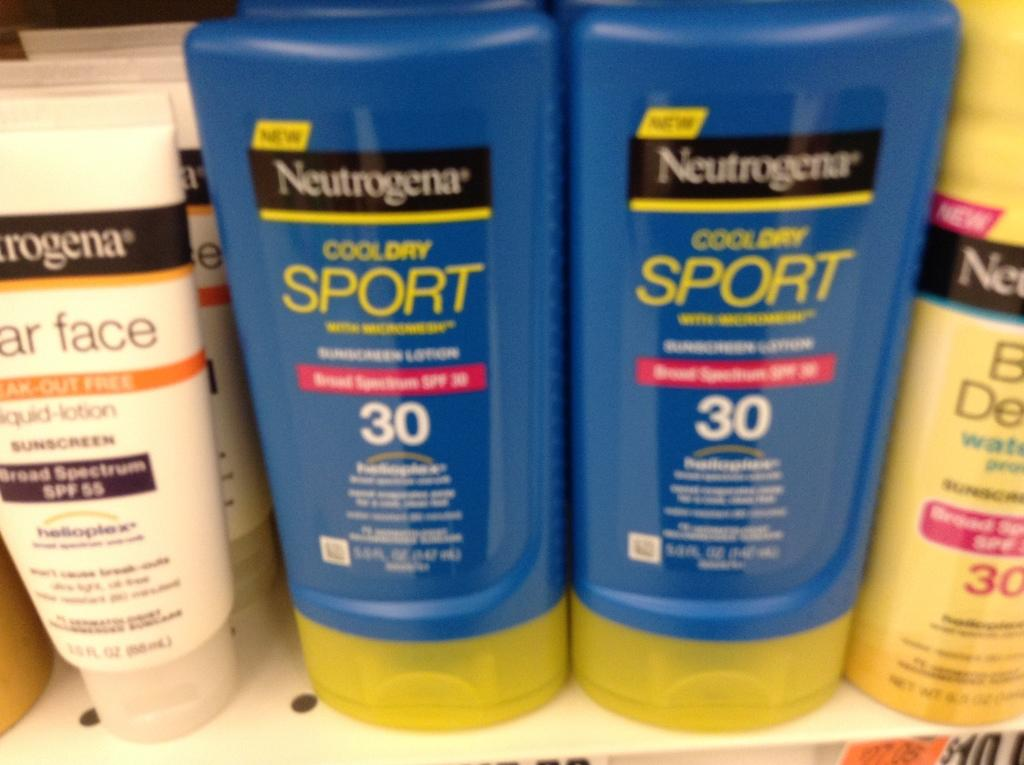<image>
Summarize the visual content of the image. Bottles of Neutrogena lotion are on a shelf. 